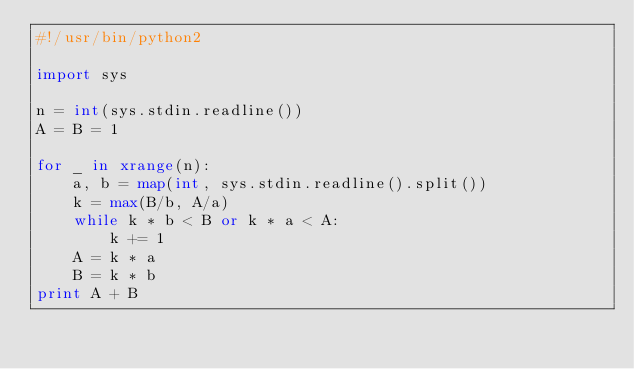<code> <loc_0><loc_0><loc_500><loc_500><_Python_>#!/usr/bin/python2

import sys

n = int(sys.stdin.readline())
A = B = 1

for _ in xrange(n):
    a, b = map(int, sys.stdin.readline().split())
    k = max(B/b, A/a)
    while k * b < B or k * a < A:
        k += 1
    A = k * a
    B = k * b
print A + B
</code> 